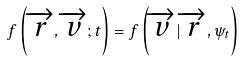<formula> <loc_0><loc_0><loc_500><loc_500>f \left ( \overrightarrow { r } , \overrightarrow { v } ; t \right ) = f \left ( \overrightarrow { v } | \overrightarrow { r } , \psi _ { t } \right )</formula> 